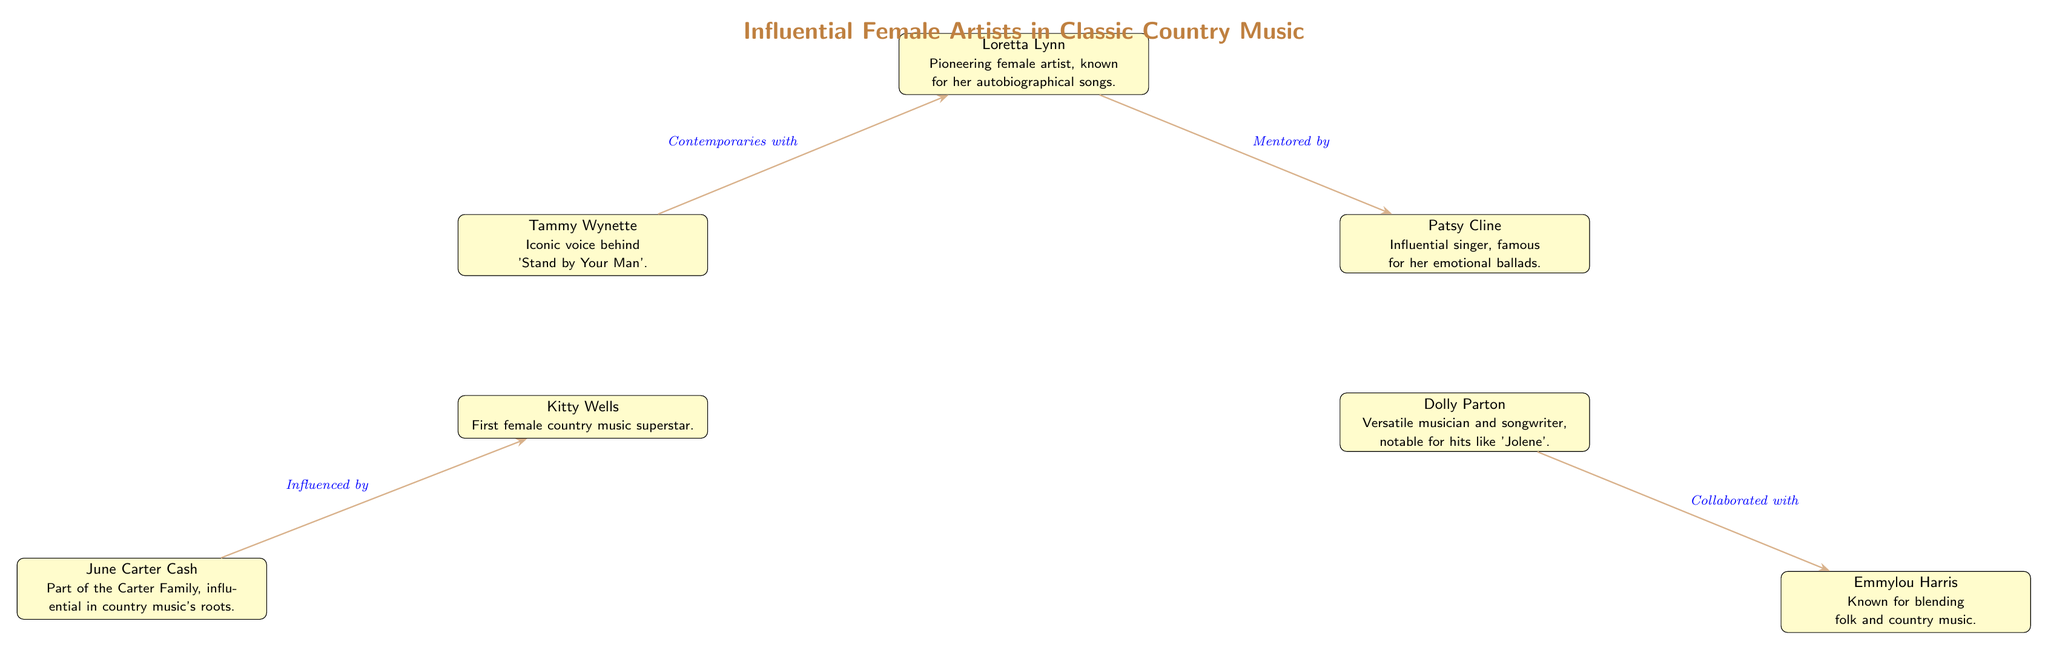What is the title of the diagram? The title is prominently displayed at the top of the diagram, stating "Influential Female Artists in Classic Country Music."
Answer: Influential Female Artists in Classic Country Music How many artists are represented in the diagram? By counting the nodes labeled as artist, there are seven distinct female artists featured in the diagram.
Answer: 7 Which artist is known for the song 'Stand by Your Man'? The diagram specifies that Tammy Wynette is recognized for her iconic voice associated with that song.
Answer: Tammy Wynette Who is the first female country music superstar according to the diagram? The diagram directly attributes the title of the first female country music superstar to Kitty Wells.
Answer: Kitty Wells What relationship connects Loretta Lynn and Patsy Cline? According to the edge connecting the two, the relationship is described as "Mentored by."
Answer: Mentored by Which artist collaborated with Emmylou Harris? The diagram indicates that Dolly Parton is the artist who collaborated with Emmylou Harris.
Answer: Dolly Parton Which two artists are contemporaries with each other? The diagram shows that Loretta Lynn and Tammy Wynette are noted as contemporaries with one another.
Answer: Loretta Lynn and Tammy Wynette Who influenced June Carter Cash? The diagram specifies that June Carter Cash was influenced by Kitty Wells, as mentioned in the connecting edge.
Answer: Kitty Wells What is the significance of the lines connecting the artists? The lines represent relationships between the artists, such as mentorship and collaboration, highlighting their connections in the country music scene.
Answer: Relationships between the artists 